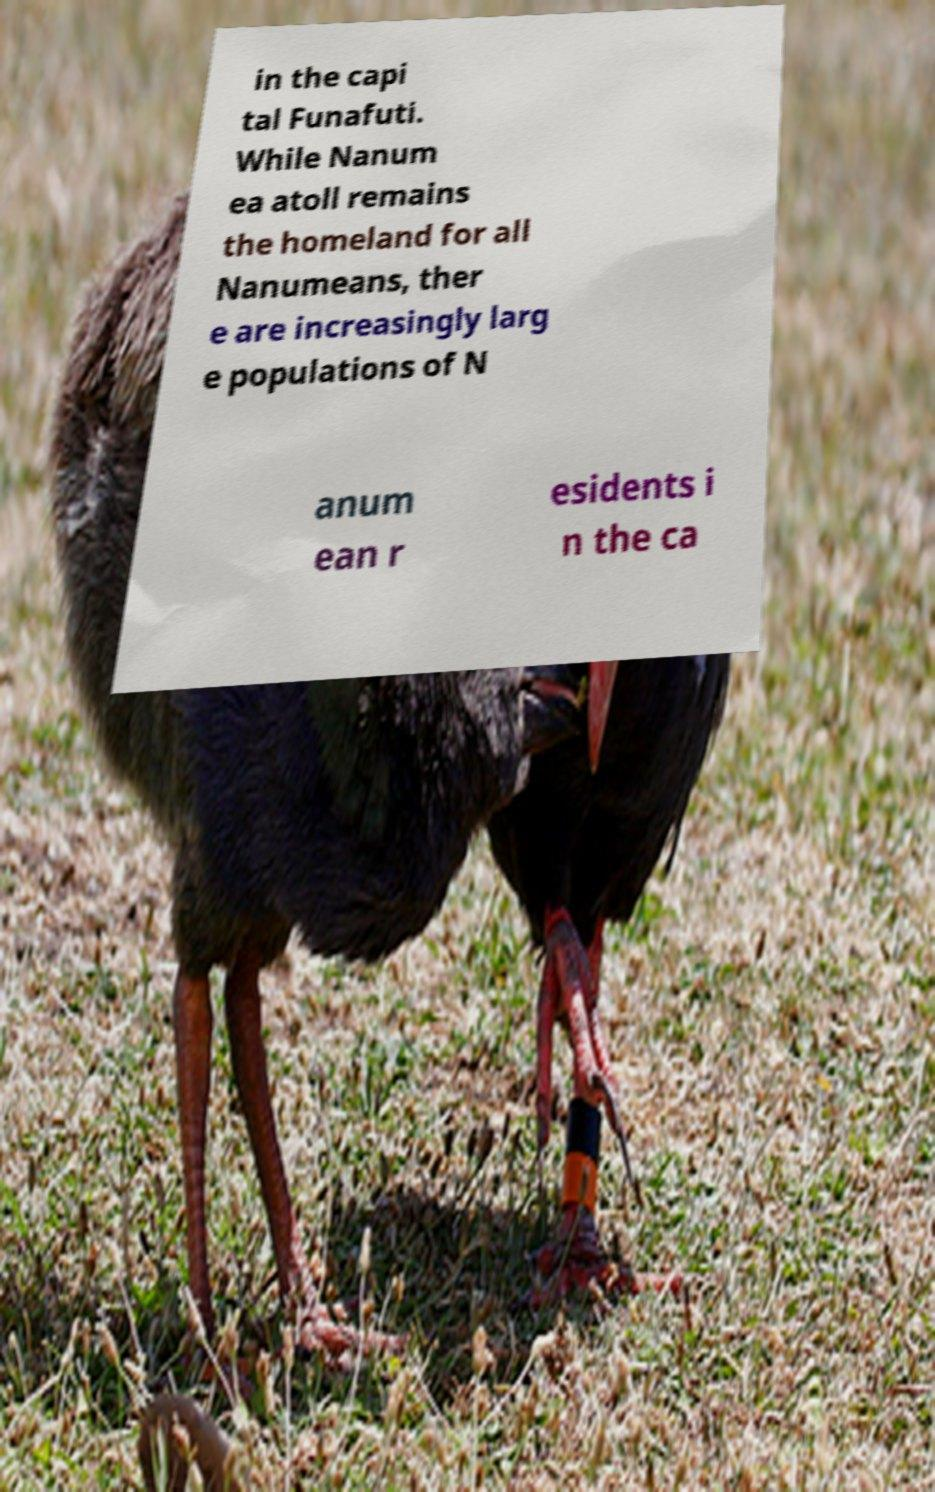Could you assist in decoding the text presented in this image and type it out clearly? in the capi tal Funafuti. While Nanum ea atoll remains the homeland for all Nanumeans, ther e are increasingly larg e populations of N anum ean r esidents i n the ca 